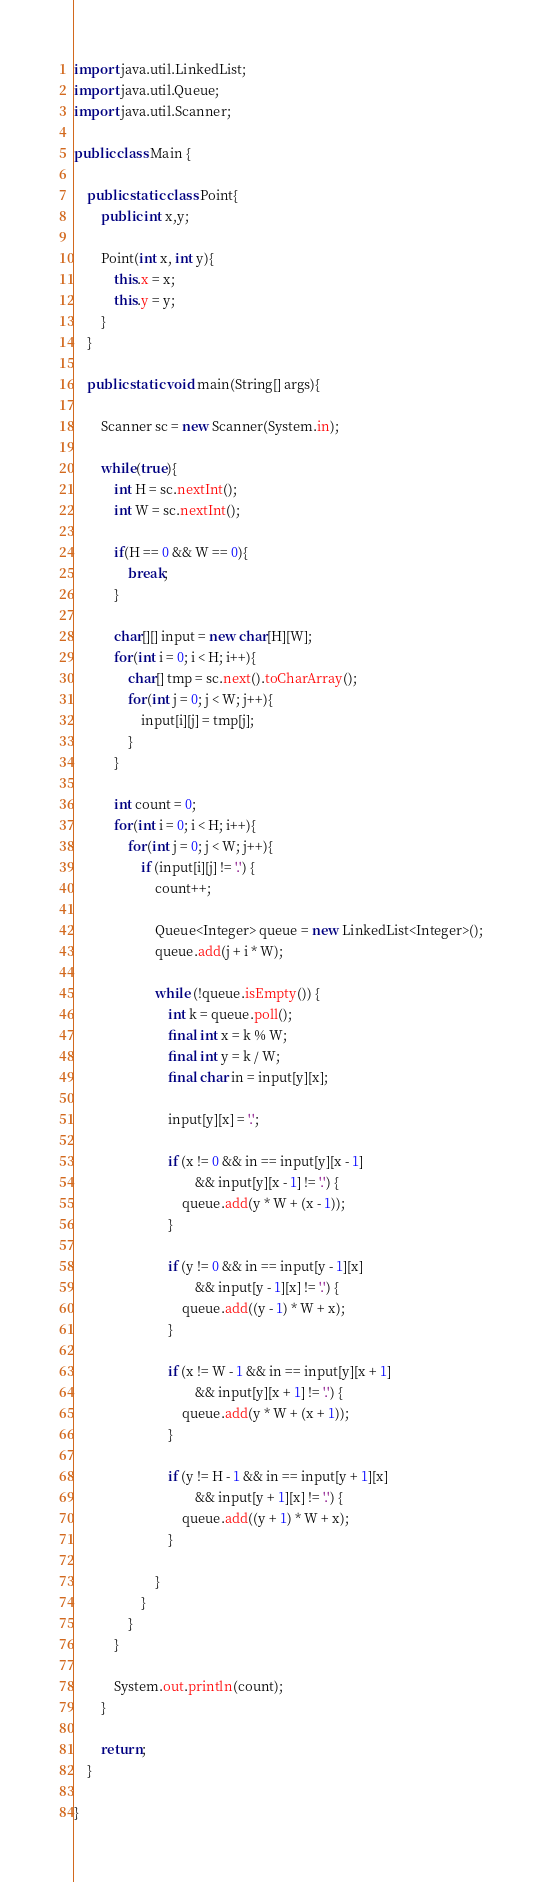<code> <loc_0><loc_0><loc_500><loc_500><_Java_>import java.util.LinkedList;
import java.util.Queue;
import java.util.Scanner;

public class Main {
	
	public static class Point{
		public int x,y;
		
		Point(int x, int y){
			this.x = x;
			this.y = y;
		}
	}
	
	public static void main(String[] args){
		
		Scanner sc = new Scanner(System.in);
		
		while(true){
			int H = sc.nextInt();
			int W = sc.nextInt();
			
			if(H == 0 && W == 0){
				break;
			}
			
			char[][] input = new char[H][W];
			for(int i = 0; i < H; i++){
				char[] tmp = sc.next().toCharArray();
				for(int j = 0; j < W; j++){
					input[i][j] = tmp[j];
				}
			}
			
			int count = 0;
			for(int i = 0; i < H; i++){
				for(int j = 0; j < W; j++){
					if (input[i][j] != '.') {
						count++;

						Queue<Integer> queue = new LinkedList<Integer>();
						queue.add(j + i * W);

						while (!queue.isEmpty()) {
							int k = queue.poll();
							final int x = k % W;
							final int y = k / W;
							final char in = input[y][x];

							input[y][x] = '.';

							if (x != 0 && in == input[y][x - 1]
									&& input[y][x - 1] != '.') {
								queue.add(y * W + (x - 1));
							}

							if (y != 0 && in == input[y - 1][x]
									&& input[y - 1][x] != '.') {
								queue.add((y - 1) * W + x);
							}

							if (x != W - 1 && in == input[y][x + 1]
									&& input[y][x + 1] != '.') {
								queue.add(y * W + (x + 1));
							}

							if (y != H - 1 && in == input[y + 1][x]
									&& input[y + 1][x] != '.') {
								queue.add((y + 1) * W + x);
							}

						}
					}
				}
			}
			
			System.out.println(count);
		}
		
		return;
	}
	
}</code> 